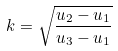<formula> <loc_0><loc_0><loc_500><loc_500>k = \sqrt { \frac { u _ { 2 } - u _ { 1 } } { u _ { 3 } - u _ { 1 } } }</formula> 